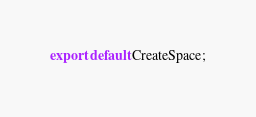<code> <loc_0><loc_0><loc_500><loc_500><_TypeScript_>
export default CreateSpace;
</code> 